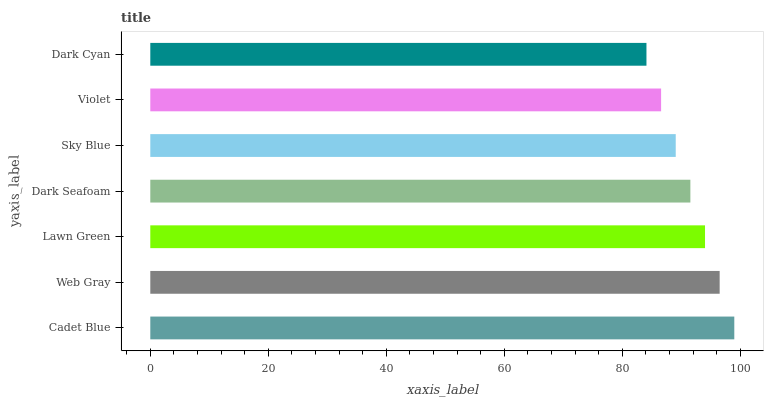Is Dark Cyan the minimum?
Answer yes or no. Yes. Is Cadet Blue the maximum?
Answer yes or no. Yes. Is Web Gray the minimum?
Answer yes or no. No. Is Web Gray the maximum?
Answer yes or no. No. Is Cadet Blue greater than Web Gray?
Answer yes or no. Yes. Is Web Gray less than Cadet Blue?
Answer yes or no. Yes. Is Web Gray greater than Cadet Blue?
Answer yes or no. No. Is Cadet Blue less than Web Gray?
Answer yes or no. No. Is Dark Seafoam the high median?
Answer yes or no. Yes. Is Dark Seafoam the low median?
Answer yes or no. Yes. Is Violet the high median?
Answer yes or no. No. Is Cadet Blue the low median?
Answer yes or no. No. 